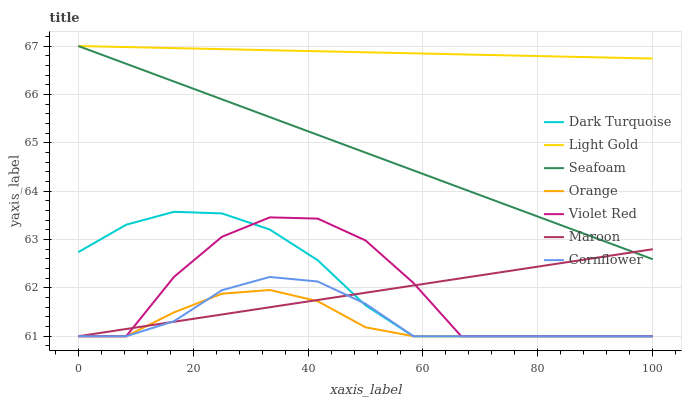Does Orange have the minimum area under the curve?
Answer yes or no. Yes. Does Light Gold have the maximum area under the curve?
Answer yes or no. Yes. Does Violet Red have the minimum area under the curve?
Answer yes or no. No. Does Violet Red have the maximum area under the curve?
Answer yes or no. No. Is Seafoam the smoothest?
Answer yes or no. Yes. Is Violet Red the roughest?
Answer yes or no. Yes. Is Dark Turquoise the smoothest?
Answer yes or no. No. Is Dark Turquoise the roughest?
Answer yes or no. No. Does Cornflower have the lowest value?
Answer yes or no. Yes. Does Seafoam have the lowest value?
Answer yes or no. No. Does Light Gold have the highest value?
Answer yes or no. Yes. Does Violet Red have the highest value?
Answer yes or no. No. Is Violet Red less than Seafoam?
Answer yes or no. Yes. Is Light Gold greater than Violet Red?
Answer yes or no. Yes. Does Orange intersect Maroon?
Answer yes or no. Yes. Is Orange less than Maroon?
Answer yes or no. No. Is Orange greater than Maroon?
Answer yes or no. No. Does Violet Red intersect Seafoam?
Answer yes or no. No. 